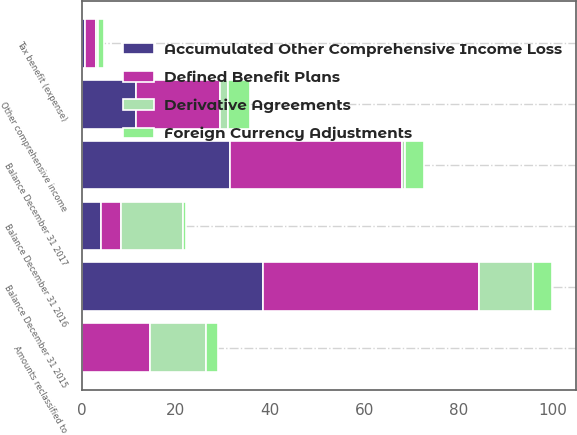Convert chart. <chart><loc_0><loc_0><loc_500><loc_500><stacked_bar_chart><ecel><fcel>Balance December 31 2015<fcel>Other comprehensive income<fcel>Amounts reclassified to<fcel>Tax benefit (expense)<fcel>Balance December 31 2016<fcel>Balance December 31 2017<nl><fcel>Accumulated Other Comprehensive Income Loss<fcel>38.5<fcel>11.5<fcel>0<fcel>0.6<fcel>4.15<fcel>31.6<nl><fcel>Derivative Agreements<fcel>11.5<fcel>1.7<fcel>11.9<fcel>0.5<fcel>13.2<fcel>0.6<nl><fcel>Foreign Currency Adjustments<fcel>4.1<fcel>4.7<fcel>2.6<fcel>1.3<fcel>0.6<fcel>4.2<nl><fcel>Defined Benefit Plans<fcel>45.9<fcel>17.9<fcel>14.5<fcel>2.4<fcel>4.15<fcel>36.4<nl></chart> 